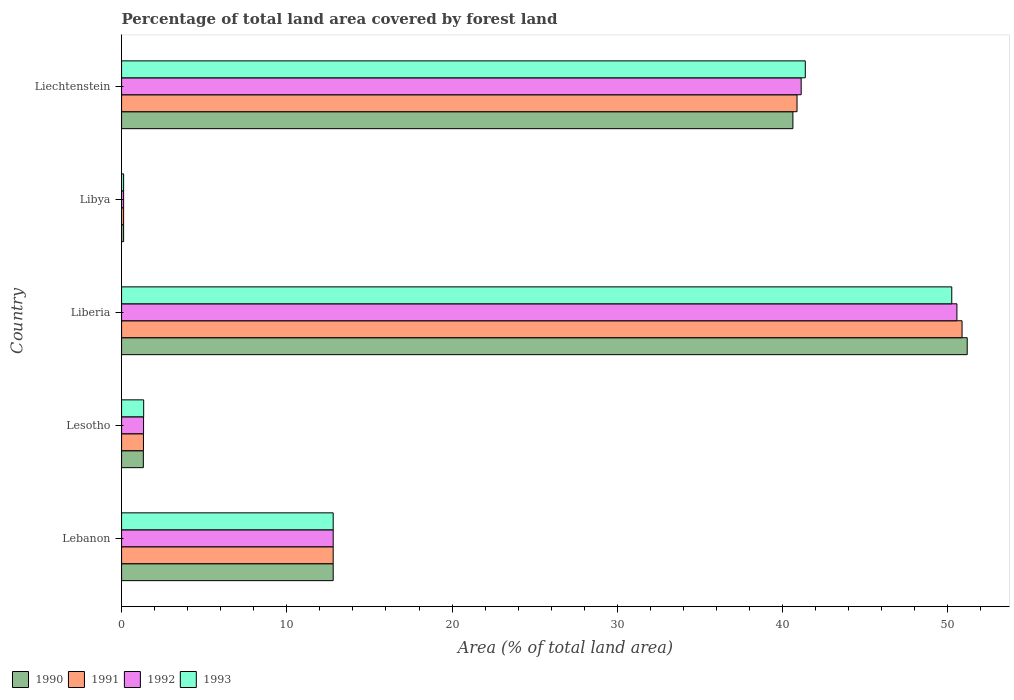How many different coloured bars are there?
Offer a terse response. 4. How many groups of bars are there?
Offer a very short reply. 5. Are the number of bars per tick equal to the number of legend labels?
Your answer should be very brief. Yes. How many bars are there on the 4th tick from the bottom?
Ensure brevity in your answer.  4. What is the label of the 2nd group of bars from the top?
Your answer should be compact. Libya. In how many cases, is the number of bars for a given country not equal to the number of legend labels?
Keep it short and to the point. 0. What is the percentage of forest land in 1992 in Lebanon?
Keep it short and to the point. 12.81. Across all countries, what is the maximum percentage of forest land in 1990?
Offer a terse response. 51.17. Across all countries, what is the minimum percentage of forest land in 1992?
Your answer should be compact. 0.12. In which country was the percentage of forest land in 1991 maximum?
Your response must be concise. Liberia. In which country was the percentage of forest land in 1993 minimum?
Make the answer very short. Libya. What is the total percentage of forest land in 1990 in the graph?
Give a very brief answer. 106.04. What is the difference between the percentage of forest land in 1992 in Lesotho and that in Liechtenstein?
Provide a short and direct response. -39.79. What is the difference between the percentage of forest land in 1991 in Liberia and the percentage of forest land in 1992 in Liechtenstein?
Provide a short and direct response. 9.74. What is the average percentage of forest land in 1993 per country?
Your answer should be very brief. 21.18. What is the ratio of the percentage of forest land in 1992 in Lesotho to that in Liechtenstein?
Ensure brevity in your answer.  0.03. Is the percentage of forest land in 1990 in Lebanon less than that in Liechtenstein?
Provide a succinct answer. Yes. Is the difference between the percentage of forest land in 1992 in Libya and Liechtenstein greater than the difference between the percentage of forest land in 1990 in Libya and Liechtenstein?
Make the answer very short. No. What is the difference between the highest and the second highest percentage of forest land in 1993?
Keep it short and to the point. 8.86. What is the difference between the highest and the lowest percentage of forest land in 1993?
Give a very brief answer. 50.12. In how many countries, is the percentage of forest land in 1992 greater than the average percentage of forest land in 1992 taken over all countries?
Give a very brief answer. 2. Is the sum of the percentage of forest land in 1992 in Lesotho and Libya greater than the maximum percentage of forest land in 1990 across all countries?
Give a very brief answer. No. What is the difference between two consecutive major ticks on the X-axis?
Ensure brevity in your answer.  10. Are the values on the major ticks of X-axis written in scientific E-notation?
Keep it short and to the point. No. How many legend labels are there?
Provide a short and direct response. 4. How are the legend labels stacked?
Provide a succinct answer. Horizontal. What is the title of the graph?
Offer a very short reply. Percentage of total land area covered by forest land. What is the label or title of the X-axis?
Offer a terse response. Area (% of total land area). What is the Area (% of total land area) of 1990 in Lebanon?
Your answer should be compact. 12.81. What is the Area (% of total land area) in 1991 in Lebanon?
Provide a succinct answer. 12.81. What is the Area (% of total land area) of 1992 in Lebanon?
Offer a terse response. 12.81. What is the Area (% of total land area) of 1993 in Lebanon?
Your response must be concise. 12.81. What is the Area (% of total land area) of 1990 in Lesotho?
Ensure brevity in your answer.  1.32. What is the Area (% of total land area) of 1991 in Lesotho?
Provide a succinct answer. 1.32. What is the Area (% of total land area) of 1992 in Lesotho?
Give a very brief answer. 1.33. What is the Area (% of total land area) in 1993 in Lesotho?
Offer a terse response. 1.34. What is the Area (% of total land area) of 1990 in Liberia?
Provide a succinct answer. 51.17. What is the Area (% of total land area) of 1991 in Liberia?
Your response must be concise. 50.86. What is the Area (% of total land area) of 1992 in Liberia?
Offer a terse response. 50.55. What is the Area (% of total land area) in 1993 in Liberia?
Your answer should be compact. 50.24. What is the Area (% of total land area) in 1990 in Libya?
Provide a succinct answer. 0.12. What is the Area (% of total land area) in 1991 in Libya?
Offer a very short reply. 0.12. What is the Area (% of total land area) of 1992 in Libya?
Ensure brevity in your answer.  0.12. What is the Area (% of total land area) in 1993 in Libya?
Provide a short and direct response. 0.12. What is the Area (% of total land area) of 1990 in Liechtenstein?
Provide a short and direct response. 40.62. What is the Area (% of total land area) of 1991 in Liechtenstein?
Offer a terse response. 40.88. What is the Area (% of total land area) in 1992 in Liechtenstein?
Make the answer very short. 41.12. What is the Area (% of total land area) of 1993 in Liechtenstein?
Provide a short and direct response. 41.38. Across all countries, what is the maximum Area (% of total land area) of 1990?
Provide a succinct answer. 51.17. Across all countries, what is the maximum Area (% of total land area) in 1991?
Your answer should be very brief. 50.86. Across all countries, what is the maximum Area (% of total land area) of 1992?
Provide a short and direct response. 50.55. Across all countries, what is the maximum Area (% of total land area) of 1993?
Provide a succinct answer. 50.24. Across all countries, what is the minimum Area (% of total land area) in 1990?
Provide a short and direct response. 0.12. Across all countries, what is the minimum Area (% of total land area) in 1991?
Ensure brevity in your answer.  0.12. Across all countries, what is the minimum Area (% of total land area) in 1992?
Your answer should be compact. 0.12. Across all countries, what is the minimum Area (% of total land area) in 1993?
Keep it short and to the point. 0.12. What is the total Area (% of total land area) in 1990 in the graph?
Your answer should be very brief. 106.04. What is the total Area (% of total land area) in 1991 in the graph?
Your answer should be compact. 105.99. What is the total Area (% of total land area) of 1992 in the graph?
Provide a short and direct response. 105.93. What is the total Area (% of total land area) in 1993 in the graph?
Your answer should be very brief. 105.88. What is the difference between the Area (% of total land area) in 1990 in Lebanon and that in Lesotho?
Keep it short and to the point. 11.49. What is the difference between the Area (% of total land area) of 1991 in Lebanon and that in Lesotho?
Keep it short and to the point. 11.48. What is the difference between the Area (% of total land area) in 1992 in Lebanon and that in Lesotho?
Your answer should be compact. 11.47. What is the difference between the Area (% of total land area) of 1993 in Lebanon and that in Lesotho?
Offer a terse response. 11.47. What is the difference between the Area (% of total land area) in 1990 in Lebanon and that in Liberia?
Provide a succinct answer. -38.37. What is the difference between the Area (% of total land area) of 1991 in Lebanon and that in Liberia?
Keep it short and to the point. -38.06. What is the difference between the Area (% of total land area) of 1992 in Lebanon and that in Liberia?
Offer a very short reply. -37.74. What is the difference between the Area (% of total land area) of 1993 in Lebanon and that in Liberia?
Give a very brief answer. -37.43. What is the difference between the Area (% of total land area) in 1990 in Lebanon and that in Libya?
Provide a succinct answer. 12.68. What is the difference between the Area (% of total land area) in 1991 in Lebanon and that in Libya?
Your answer should be very brief. 12.68. What is the difference between the Area (% of total land area) in 1992 in Lebanon and that in Libya?
Your answer should be very brief. 12.68. What is the difference between the Area (% of total land area) of 1993 in Lebanon and that in Libya?
Your response must be concise. 12.68. What is the difference between the Area (% of total land area) in 1990 in Lebanon and that in Liechtenstein?
Offer a terse response. -27.82. What is the difference between the Area (% of total land area) of 1991 in Lebanon and that in Liechtenstein?
Make the answer very short. -28.07. What is the difference between the Area (% of total land area) in 1992 in Lebanon and that in Liechtenstein?
Provide a succinct answer. -28.32. What is the difference between the Area (% of total land area) in 1993 in Lebanon and that in Liechtenstein?
Offer a very short reply. -28.57. What is the difference between the Area (% of total land area) of 1990 in Lesotho and that in Liberia?
Keep it short and to the point. -49.86. What is the difference between the Area (% of total land area) in 1991 in Lesotho and that in Liberia?
Ensure brevity in your answer.  -49.54. What is the difference between the Area (% of total land area) in 1992 in Lesotho and that in Liberia?
Provide a short and direct response. -49.22. What is the difference between the Area (% of total land area) in 1993 in Lesotho and that in Liberia?
Make the answer very short. -48.9. What is the difference between the Area (% of total land area) in 1990 in Lesotho and that in Libya?
Make the answer very short. 1.19. What is the difference between the Area (% of total land area) in 1991 in Lesotho and that in Libya?
Your answer should be compact. 1.2. What is the difference between the Area (% of total land area) of 1992 in Lesotho and that in Libya?
Your answer should be very brief. 1.21. What is the difference between the Area (% of total land area) of 1993 in Lesotho and that in Libya?
Your answer should be compact. 1.21. What is the difference between the Area (% of total land area) in 1990 in Lesotho and that in Liechtenstein?
Provide a short and direct response. -39.31. What is the difference between the Area (% of total land area) of 1991 in Lesotho and that in Liechtenstein?
Your response must be concise. -39.55. What is the difference between the Area (% of total land area) of 1992 in Lesotho and that in Liechtenstein?
Your response must be concise. -39.79. What is the difference between the Area (% of total land area) in 1993 in Lesotho and that in Liechtenstein?
Offer a terse response. -40.04. What is the difference between the Area (% of total land area) of 1990 in Liberia and that in Libya?
Provide a short and direct response. 51.05. What is the difference between the Area (% of total land area) of 1991 in Liberia and that in Libya?
Your answer should be very brief. 50.74. What is the difference between the Area (% of total land area) of 1992 in Liberia and that in Libya?
Provide a succinct answer. 50.43. What is the difference between the Area (% of total land area) of 1993 in Liberia and that in Libya?
Offer a terse response. 50.12. What is the difference between the Area (% of total land area) of 1990 in Liberia and that in Liechtenstein?
Your answer should be very brief. 10.55. What is the difference between the Area (% of total land area) of 1991 in Liberia and that in Liechtenstein?
Make the answer very short. 9.99. What is the difference between the Area (% of total land area) in 1992 in Liberia and that in Liechtenstein?
Offer a terse response. 9.43. What is the difference between the Area (% of total land area) in 1993 in Liberia and that in Liechtenstein?
Provide a short and direct response. 8.86. What is the difference between the Area (% of total land area) in 1990 in Libya and that in Liechtenstein?
Keep it short and to the point. -40.5. What is the difference between the Area (% of total land area) of 1991 in Libya and that in Liechtenstein?
Offer a very short reply. -40.75. What is the difference between the Area (% of total land area) of 1992 in Libya and that in Liechtenstein?
Your response must be concise. -41. What is the difference between the Area (% of total land area) in 1993 in Libya and that in Liechtenstein?
Keep it short and to the point. -41.25. What is the difference between the Area (% of total land area) of 1990 in Lebanon and the Area (% of total land area) of 1991 in Lesotho?
Give a very brief answer. 11.48. What is the difference between the Area (% of total land area) of 1990 in Lebanon and the Area (% of total land area) of 1992 in Lesotho?
Your answer should be compact. 11.47. What is the difference between the Area (% of total land area) in 1990 in Lebanon and the Area (% of total land area) in 1993 in Lesotho?
Provide a short and direct response. 11.47. What is the difference between the Area (% of total land area) of 1991 in Lebanon and the Area (% of total land area) of 1992 in Lesotho?
Your answer should be very brief. 11.47. What is the difference between the Area (% of total land area) in 1991 in Lebanon and the Area (% of total land area) in 1993 in Lesotho?
Provide a succinct answer. 11.47. What is the difference between the Area (% of total land area) in 1992 in Lebanon and the Area (% of total land area) in 1993 in Lesotho?
Provide a short and direct response. 11.47. What is the difference between the Area (% of total land area) in 1990 in Lebanon and the Area (% of total land area) in 1991 in Liberia?
Your answer should be very brief. -38.06. What is the difference between the Area (% of total land area) of 1990 in Lebanon and the Area (% of total land area) of 1992 in Liberia?
Offer a very short reply. -37.74. What is the difference between the Area (% of total land area) in 1990 in Lebanon and the Area (% of total land area) in 1993 in Liberia?
Offer a terse response. -37.43. What is the difference between the Area (% of total land area) in 1991 in Lebanon and the Area (% of total land area) in 1992 in Liberia?
Provide a short and direct response. -37.74. What is the difference between the Area (% of total land area) of 1991 in Lebanon and the Area (% of total land area) of 1993 in Liberia?
Keep it short and to the point. -37.43. What is the difference between the Area (% of total land area) in 1992 in Lebanon and the Area (% of total land area) in 1993 in Liberia?
Keep it short and to the point. -37.43. What is the difference between the Area (% of total land area) of 1990 in Lebanon and the Area (% of total land area) of 1991 in Libya?
Offer a very short reply. 12.68. What is the difference between the Area (% of total land area) of 1990 in Lebanon and the Area (% of total land area) of 1992 in Libya?
Your response must be concise. 12.68. What is the difference between the Area (% of total land area) of 1990 in Lebanon and the Area (% of total land area) of 1993 in Libya?
Make the answer very short. 12.68. What is the difference between the Area (% of total land area) in 1991 in Lebanon and the Area (% of total land area) in 1992 in Libya?
Make the answer very short. 12.68. What is the difference between the Area (% of total land area) of 1991 in Lebanon and the Area (% of total land area) of 1993 in Libya?
Keep it short and to the point. 12.68. What is the difference between the Area (% of total land area) in 1992 in Lebanon and the Area (% of total land area) in 1993 in Libya?
Provide a short and direct response. 12.68. What is the difference between the Area (% of total land area) in 1990 in Lebanon and the Area (% of total land area) in 1991 in Liechtenstein?
Provide a succinct answer. -28.07. What is the difference between the Area (% of total land area) in 1990 in Lebanon and the Area (% of total land area) in 1992 in Liechtenstein?
Offer a terse response. -28.32. What is the difference between the Area (% of total land area) of 1990 in Lebanon and the Area (% of total land area) of 1993 in Liechtenstein?
Provide a succinct answer. -28.57. What is the difference between the Area (% of total land area) in 1991 in Lebanon and the Area (% of total land area) in 1992 in Liechtenstein?
Provide a succinct answer. -28.32. What is the difference between the Area (% of total land area) in 1991 in Lebanon and the Area (% of total land area) in 1993 in Liechtenstein?
Keep it short and to the point. -28.57. What is the difference between the Area (% of total land area) of 1992 in Lebanon and the Area (% of total land area) of 1993 in Liechtenstein?
Make the answer very short. -28.57. What is the difference between the Area (% of total land area) in 1990 in Lesotho and the Area (% of total land area) in 1991 in Liberia?
Ensure brevity in your answer.  -49.54. What is the difference between the Area (% of total land area) of 1990 in Lesotho and the Area (% of total land area) of 1992 in Liberia?
Your answer should be very brief. -49.23. What is the difference between the Area (% of total land area) in 1990 in Lesotho and the Area (% of total land area) in 1993 in Liberia?
Provide a succinct answer. -48.92. What is the difference between the Area (% of total land area) of 1991 in Lesotho and the Area (% of total land area) of 1992 in Liberia?
Keep it short and to the point. -49.23. What is the difference between the Area (% of total land area) in 1991 in Lesotho and the Area (% of total land area) in 1993 in Liberia?
Make the answer very short. -48.91. What is the difference between the Area (% of total land area) in 1992 in Lesotho and the Area (% of total land area) in 1993 in Liberia?
Provide a short and direct response. -48.91. What is the difference between the Area (% of total land area) in 1990 in Lesotho and the Area (% of total land area) in 1991 in Libya?
Your answer should be compact. 1.19. What is the difference between the Area (% of total land area) of 1990 in Lesotho and the Area (% of total land area) of 1992 in Libya?
Keep it short and to the point. 1.19. What is the difference between the Area (% of total land area) of 1990 in Lesotho and the Area (% of total land area) of 1993 in Libya?
Provide a short and direct response. 1.19. What is the difference between the Area (% of total land area) of 1991 in Lesotho and the Area (% of total land area) of 1992 in Libya?
Offer a terse response. 1.2. What is the difference between the Area (% of total land area) in 1991 in Lesotho and the Area (% of total land area) in 1993 in Libya?
Give a very brief answer. 1.2. What is the difference between the Area (% of total land area) of 1992 in Lesotho and the Area (% of total land area) of 1993 in Libya?
Offer a very short reply. 1.21. What is the difference between the Area (% of total land area) of 1990 in Lesotho and the Area (% of total land area) of 1991 in Liechtenstein?
Provide a succinct answer. -39.56. What is the difference between the Area (% of total land area) in 1990 in Lesotho and the Area (% of total land area) in 1992 in Liechtenstein?
Offer a terse response. -39.81. What is the difference between the Area (% of total land area) of 1990 in Lesotho and the Area (% of total land area) of 1993 in Liechtenstein?
Your response must be concise. -40.06. What is the difference between the Area (% of total land area) in 1991 in Lesotho and the Area (% of total land area) in 1992 in Liechtenstein?
Provide a succinct answer. -39.8. What is the difference between the Area (% of total land area) in 1991 in Lesotho and the Area (% of total land area) in 1993 in Liechtenstein?
Ensure brevity in your answer.  -40.05. What is the difference between the Area (% of total land area) of 1992 in Lesotho and the Area (% of total land area) of 1993 in Liechtenstein?
Provide a succinct answer. -40.04. What is the difference between the Area (% of total land area) in 1990 in Liberia and the Area (% of total land area) in 1991 in Libya?
Your answer should be very brief. 51.05. What is the difference between the Area (% of total land area) of 1990 in Liberia and the Area (% of total land area) of 1992 in Libya?
Provide a succinct answer. 51.05. What is the difference between the Area (% of total land area) of 1990 in Liberia and the Area (% of total land area) of 1993 in Libya?
Your response must be concise. 51.05. What is the difference between the Area (% of total land area) of 1991 in Liberia and the Area (% of total land area) of 1992 in Libya?
Your response must be concise. 50.74. What is the difference between the Area (% of total land area) of 1991 in Liberia and the Area (% of total land area) of 1993 in Libya?
Keep it short and to the point. 50.74. What is the difference between the Area (% of total land area) in 1992 in Liberia and the Area (% of total land area) in 1993 in Libya?
Keep it short and to the point. 50.43. What is the difference between the Area (% of total land area) in 1990 in Liberia and the Area (% of total land area) in 1991 in Liechtenstein?
Your response must be concise. 10.3. What is the difference between the Area (% of total land area) in 1990 in Liberia and the Area (% of total land area) in 1992 in Liechtenstein?
Offer a very short reply. 10.05. What is the difference between the Area (% of total land area) in 1990 in Liberia and the Area (% of total land area) in 1993 in Liechtenstein?
Offer a very short reply. 9.8. What is the difference between the Area (% of total land area) in 1991 in Liberia and the Area (% of total land area) in 1992 in Liechtenstein?
Give a very brief answer. 9.74. What is the difference between the Area (% of total land area) of 1991 in Liberia and the Area (% of total land area) of 1993 in Liechtenstein?
Your answer should be compact. 9.49. What is the difference between the Area (% of total land area) of 1992 in Liberia and the Area (% of total land area) of 1993 in Liechtenstein?
Your response must be concise. 9.18. What is the difference between the Area (% of total land area) in 1990 in Libya and the Area (% of total land area) in 1991 in Liechtenstein?
Ensure brevity in your answer.  -40.75. What is the difference between the Area (% of total land area) of 1990 in Libya and the Area (% of total land area) of 1992 in Liechtenstein?
Your answer should be compact. -41. What is the difference between the Area (% of total land area) in 1990 in Libya and the Area (% of total land area) in 1993 in Liechtenstein?
Your response must be concise. -41.25. What is the difference between the Area (% of total land area) of 1991 in Libya and the Area (% of total land area) of 1992 in Liechtenstein?
Your response must be concise. -41. What is the difference between the Area (% of total land area) in 1991 in Libya and the Area (% of total land area) in 1993 in Liechtenstein?
Your answer should be compact. -41.25. What is the difference between the Area (% of total land area) of 1992 in Libya and the Area (% of total land area) of 1993 in Liechtenstein?
Provide a succinct answer. -41.25. What is the average Area (% of total land area) in 1990 per country?
Offer a very short reply. 21.21. What is the average Area (% of total land area) in 1991 per country?
Your response must be concise. 21.2. What is the average Area (% of total land area) of 1992 per country?
Your answer should be compact. 21.19. What is the average Area (% of total land area) of 1993 per country?
Your response must be concise. 21.18. What is the difference between the Area (% of total land area) of 1990 and Area (% of total land area) of 1992 in Lebanon?
Provide a short and direct response. 0. What is the difference between the Area (% of total land area) in 1990 and Area (% of total land area) in 1993 in Lebanon?
Offer a terse response. 0. What is the difference between the Area (% of total land area) of 1990 and Area (% of total land area) of 1991 in Lesotho?
Give a very brief answer. -0.01. What is the difference between the Area (% of total land area) in 1990 and Area (% of total land area) in 1992 in Lesotho?
Ensure brevity in your answer.  -0.01. What is the difference between the Area (% of total land area) of 1990 and Area (% of total land area) of 1993 in Lesotho?
Offer a terse response. -0.02. What is the difference between the Area (% of total land area) of 1991 and Area (% of total land area) of 1992 in Lesotho?
Keep it short and to the point. -0.01. What is the difference between the Area (% of total land area) in 1991 and Area (% of total land area) in 1993 in Lesotho?
Provide a succinct answer. -0.01. What is the difference between the Area (% of total land area) in 1992 and Area (% of total land area) in 1993 in Lesotho?
Make the answer very short. -0.01. What is the difference between the Area (% of total land area) in 1990 and Area (% of total land area) in 1991 in Liberia?
Keep it short and to the point. 0.31. What is the difference between the Area (% of total land area) in 1990 and Area (% of total land area) in 1992 in Liberia?
Your answer should be very brief. 0.62. What is the difference between the Area (% of total land area) in 1990 and Area (% of total land area) in 1993 in Liberia?
Make the answer very short. 0.93. What is the difference between the Area (% of total land area) of 1991 and Area (% of total land area) of 1992 in Liberia?
Make the answer very short. 0.31. What is the difference between the Area (% of total land area) in 1991 and Area (% of total land area) in 1993 in Liberia?
Make the answer very short. 0.62. What is the difference between the Area (% of total land area) of 1992 and Area (% of total land area) of 1993 in Liberia?
Give a very brief answer. 0.31. What is the difference between the Area (% of total land area) of 1990 and Area (% of total land area) of 1993 in Libya?
Offer a very short reply. 0. What is the difference between the Area (% of total land area) in 1991 and Area (% of total land area) in 1992 in Libya?
Your answer should be compact. 0. What is the difference between the Area (% of total land area) of 1991 and Area (% of total land area) of 1993 in Libya?
Your response must be concise. 0. What is the difference between the Area (% of total land area) of 1990 and Area (% of total land area) of 1992 in Liechtenstein?
Make the answer very short. -0.5. What is the difference between the Area (% of total land area) in 1990 and Area (% of total land area) in 1993 in Liechtenstein?
Provide a succinct answer. -0.75. What is the difference between the Area (% of total land area) of 1992 and Area (% of total land area) of 1993 in Liechtenstein?
Make the answer very short. -0.25. What is the ratio of the Area (% of total land area) of 1990 in Lebanon to that in Lesotho?
Your response must be concise. 9.72. What is the ratio of the Area (% of total land area) of 1991 in Lebanon to that in Lesotho?
Offer a terse response. 9.67. What is the ratio of the Area (% of total land area) of 1992 in Lebanon to that in Lesotho?
Give a very brief answer. 9.62. What is the ratio of the Area (% of total land area) in 1993 in Lebanon to that in Lesotho?
Offer a terse response. 9.58. What is the ratio of the Area (% of total land area) of 1990 in Lebanon to that in Liberia?
Ensure brevity in your answer.  0.25. What is the ratio of the Area (% of total land area) in 1991 in Lebanon to that in Liberia?
Give a very brief answer. 0.25. What is the ratio of the Area (% of total land area) of 1992 in Lebanon to that in Liberia?
Make the answer very short. 0.25. What is the ratio of the Area (% of total land area) of 1993 in Lebanon to that in Liberia?
Your answer should be compact. 0.25. What is the ratio of the Area (% of total land area) of 1990 in Lebanon to that in Libya?
Make the answer very short. 103.83. What is the ratio of the Area (% of total land area) in 1991 in Lebanon to that in Libya?
Your answer should be compact. 103.83. What is the ratio of the Area (% of total land area) in 1992 in Lebanon to that in Libya?
Provide a succinct answer. 103.83. What is the ratio of the Area (% of total land area) of 1993 in Lebanon to that in Libya?
Your response must be concise. 103.83. What is the ratio of the Area (% of total land area) in 1990 in Lebanon to that in Liechtenstein?
Offer a very short reply. 0.32. What is the ratio of the Area (% of total land area) of 1991 in Lebanon to that in Liechtenstein?
Keep it short and to the point. 0.31. What is the ratio of the Area (% of total land area) of 1992 in Lebanon to that in Liechtenstein?
Give a very brief answer. 0.31. What is the ratio of the Area (% of total land area) of 1993 in Lebanon to that in Liechtenstein?
Ensure brevity in your answer.  0.31. What is the ratio of the Area (% of total land area) in 1990 in Lesotho to that in Liberia?
Make the answer very short. 0.03. What is the ratio of the Area (% of total land area) of 1991 in Lesotho to that in Liberia?
Your response must be concise. 0.03. What is the ratio of the Area (% of total land area) in 1992 in Lesotho to that in Liberia?
Make the answer very short. 0.03. What is the ratio of the Area (% of total land area) of 1993 in Lesotho to that in Liberia?
Keep it short and to the point. 0.03. What is the ratio of the Area (% of total land area) in 1990 in Lesotho to that in Libya?
Give a very brief answer. 10.68. What is the ratio of the Area (% of total land area) of 1991 in Lesotho to that in Libya?
Your response must be concise. 10.74. What is the ratio of the Area (% of total land area) in 1992 in Lesotho to that in Libya?
Offer a very short reply. 10.79. What is the ratio of the Area (% of total land area) in 1993 in Lesotho to that in Libya?
Your answer should be compact. 10.84. What is the ratio of the Area (% of total land area) of 1990 in Lesotho to that in Liechtenstein?
Offer a very short reply. 0.03. What is the ratio of the Area (% of total land area) of 1991 in Lesotho to that in Liechtenstein?
Make the answer very short. 0.03. What is the ratio of the Area (% of total land area) in 1992 in Lesotho to that in Liechtenstein?
Your response must be concise. 0.03. What is the ratio of the Area (% of total land area) of 1993 in Lesotho to that in Liechtenstein?
Provide a succinct answer. 0.03. What is the ratio of the Area (% of total land area) in 1990 in Liberia to that in Libya?
Ensure brevity in your answer.  414.94. What is the ratio of the Area (% of total land area) of 1991 in Liberia to that in Libya?
Your answer should be compact. 412.41. What is the ratio of the Area (% of total land area) in 1992 in Liberia to that in Libya?
Keep it short and to the point. 409.89. What is the ratio of the Area (% of total land area) in 1993 in Liberia to that in Libya?
Ensure brevity in your answer.  407.36. What is the ratio of the Area (% of total land area) in 1990 in Liberia to that in Liechtenstein?
Provide a short and direct response. 1.26. What is the ratio of the Area (% of total land area) in 1991 in Liberia to that in Liechtenstein?
Your response must be concise. 1.24. What is the ratio of the Area (% of total land area) in 1992 in Liberia to that in Liechtenstein?
Ensure brevity in your answer.  1.23. What is the ratio of the Area (% of total land area) of 1993 in Liberia to that in Liechtenstein?
Keep it short and to the point. 1.21. What is the ratio of the Area (% of total land area) in 1990 in Libya to that in Liechtenstein?
Provide a short and direct response. 0. What is the ratio of the Area (% of total land area) of 1991 in Libya to that in Liechtenstein?
Offer a terse response. 0. What is the ratio of the Area (% of total land area) of 1992 in Libya to that in Liechtenstein?
Keep it short and to the point. 0. What is the ratio of the Area (% of total land area) in 1993 in Libya to that in Liechtenstein?
Provide a succinct answer. 0. What is the difference between the highest and the second highest Area (% of total land area) of 1990?
Your response must be concise. 10.55. What is the difference between the highest and the second highest Area (% of total land area) of 1991?
Ensure brevity in your answer.  9.99. What is the difference between the highest and the second highest Area (% of total land area) of 1992?
Provide a succinct answer. 9.43. What is the difference between the highest and the second highest Area (% of total land area) in 1993?
Your response must be concise. 8.86. What is the difference between the highest and the lowest Area (% of total land area) of 1990?
Offer a terse response. 51.05. What is the difference between the highest and the lowest Area (% of total land area) of 1991?
Your answer should be very brief. 50.74. What is the difference between the highest and the lowest Area (% of total land area) in 1992?
Your answer should be very brief. 50.43. What is the difference between the highest and the lowest Area (% of total land area) of 1993?
Give a very brief answer. 50.12. 